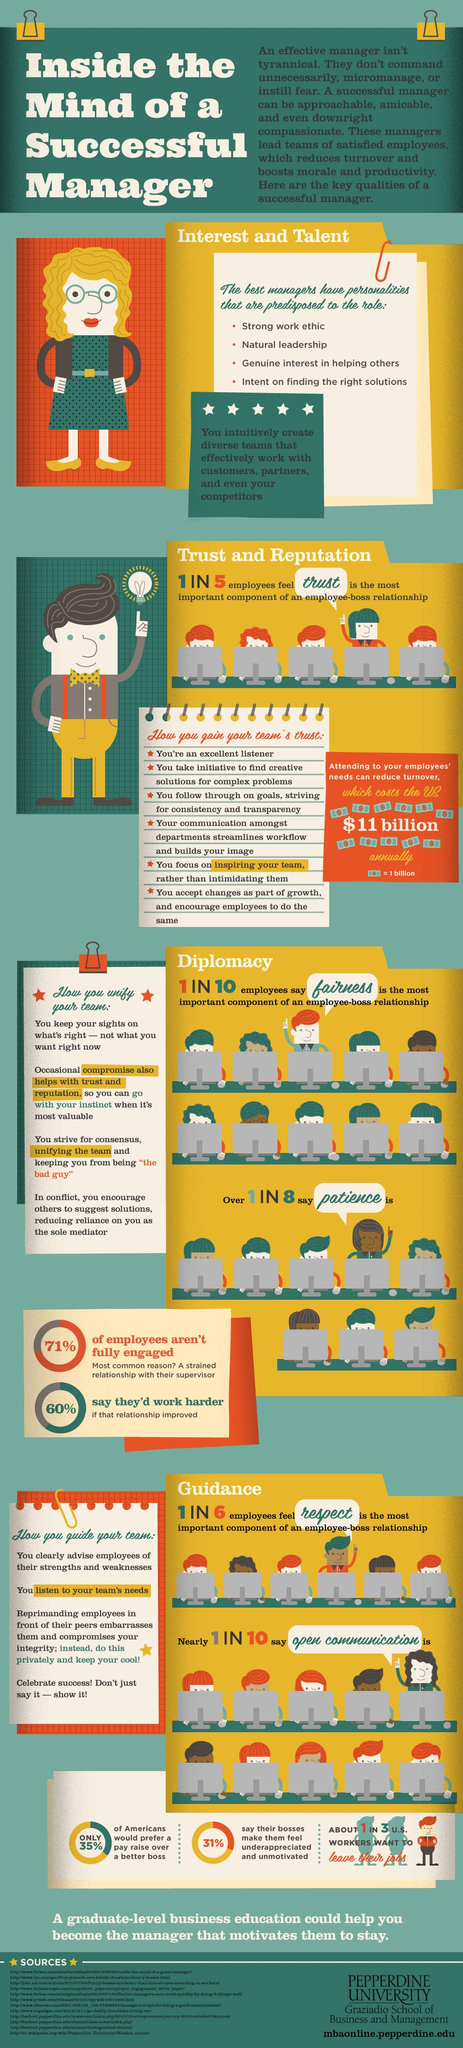Mention a couple of crucial points in this snapshot. According to the data, 35% of employees prefer a pay rise over a better boss, while 31% say that their current boss makes them feel underappreciated and unmotivated. Fairness and patience are key aspects of managerial skills, and diplomacy is the skill that embodies them. Respect and open communication are critical aspects of managerial skills, as they provide guidance to employees. According to a recent survey, 10% of employees believe that open communication is critical to their workplace satisfaction and success. According to a recent survey, it was found that approximately 20% of employees believe that trust is the most important component of the employee-boss relationship. 